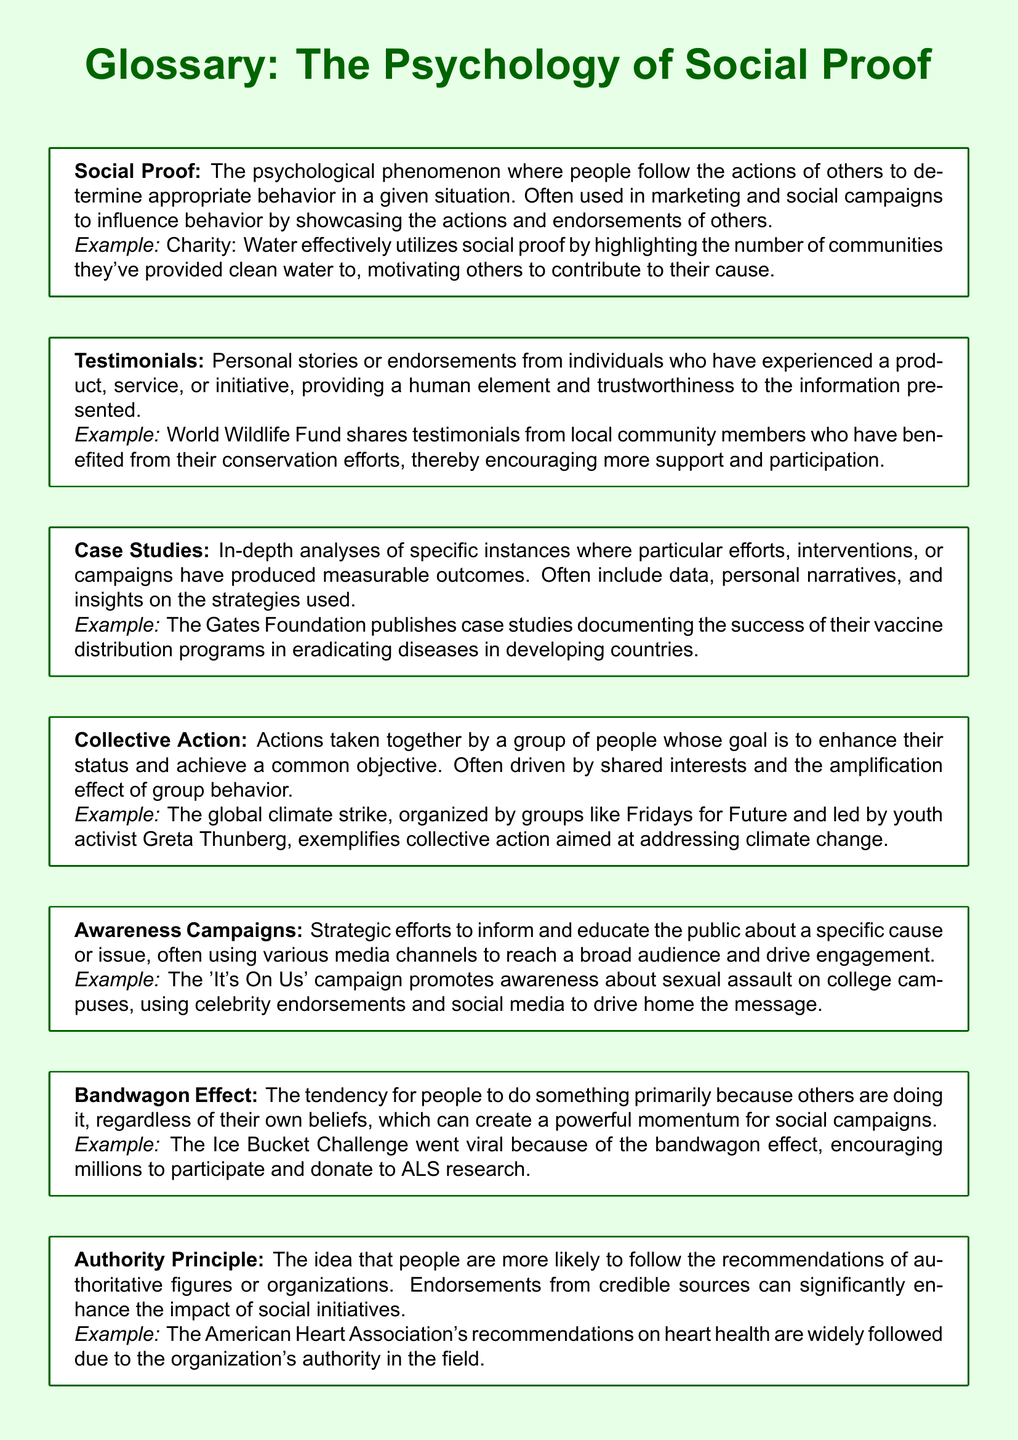What is the psychological phenomenon where people follow others to determine appropriate behavior? The document defines social proof as the psychological phenomenon where people follow the actions of others to determine appropriate behavior in a given situation.
Answer: Social Proof Which organization shares testimonials from local community members about conservation efforts? The document mentions the World Wildlife Fund as the organization sharing such testimonials to encourage support and participation.
Answer: World Wildlife Fund What kind of campaigns aim to enhance a group's status and achieve a common objective? The document describes collective action as the actions taken together by a group to enhance their status and achieve a common objective.
Answer: Collective Action What is an example of a campaign that uses celebrity endorsements to drive awareness? The document provides the example of the 'It's On Us' campaign, which promotes awareness about sexual assault on college campuses using celebrity endorsements.
Answer: It's On Us What principle suggests people are likely to follow recommendations from authoritative figures? The authority principle states that people are more likely to follow recommendations from authoritative figures or organizations.
Answer: Authority Principle Which campaign went viral due to the bandwagon effect? The document cites the Ice Bucket Challenge as an example that went viral because of the bandwagon effect, encouraging donations to ALS research.
Answer: Ice Bucket Challenge What type of analysis provides in-depth examples of successful initiatives? The document describes case studies as in-depth analyses of specific instances where efforts produced measurable outcomes.
Answer: Case Studies What does an awareness campaign aim to do? According to the document, awareness campaigns aim to inform and educate the public about a specific cause or issue.
Answer: Inform and educate 